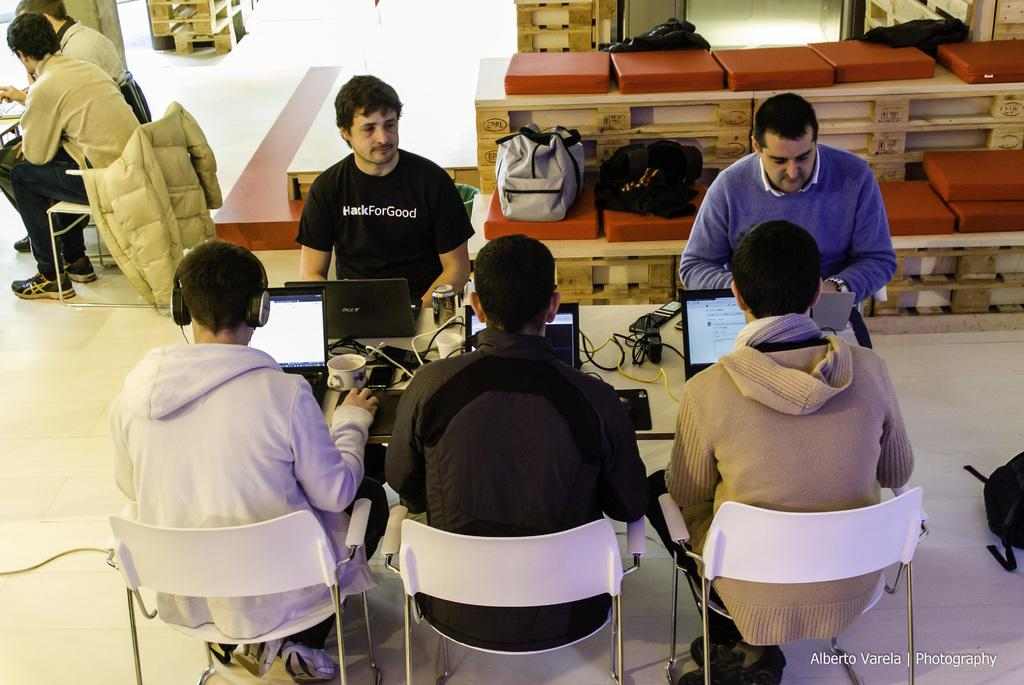How many people are in the image? There is a group of people in the image. What are the people doing in the image? The people are seated on chairs. What is on the table in the image? There are laptops and tea cups on the table. Where are the backpacks located in the image? The backpacks are on a bench. What type of seed is present in the image? There is no seed present in the image. 